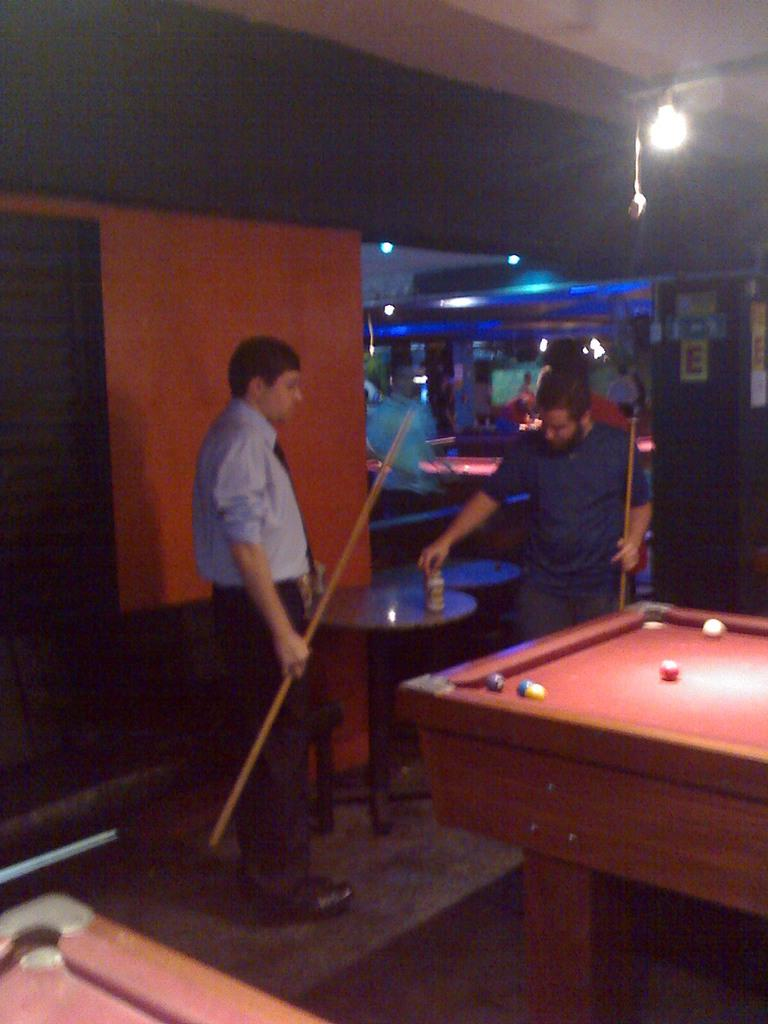How many people are in the image? There are two people in the image. What are the two people doing in the image? The two people are playing a snookers game. Can you describe the lighting in the image? There is a light above the snookers table. What song is being sung by the people in the image? There is no indication in the image that the people are singing a song, as they are playing a snookers game. 